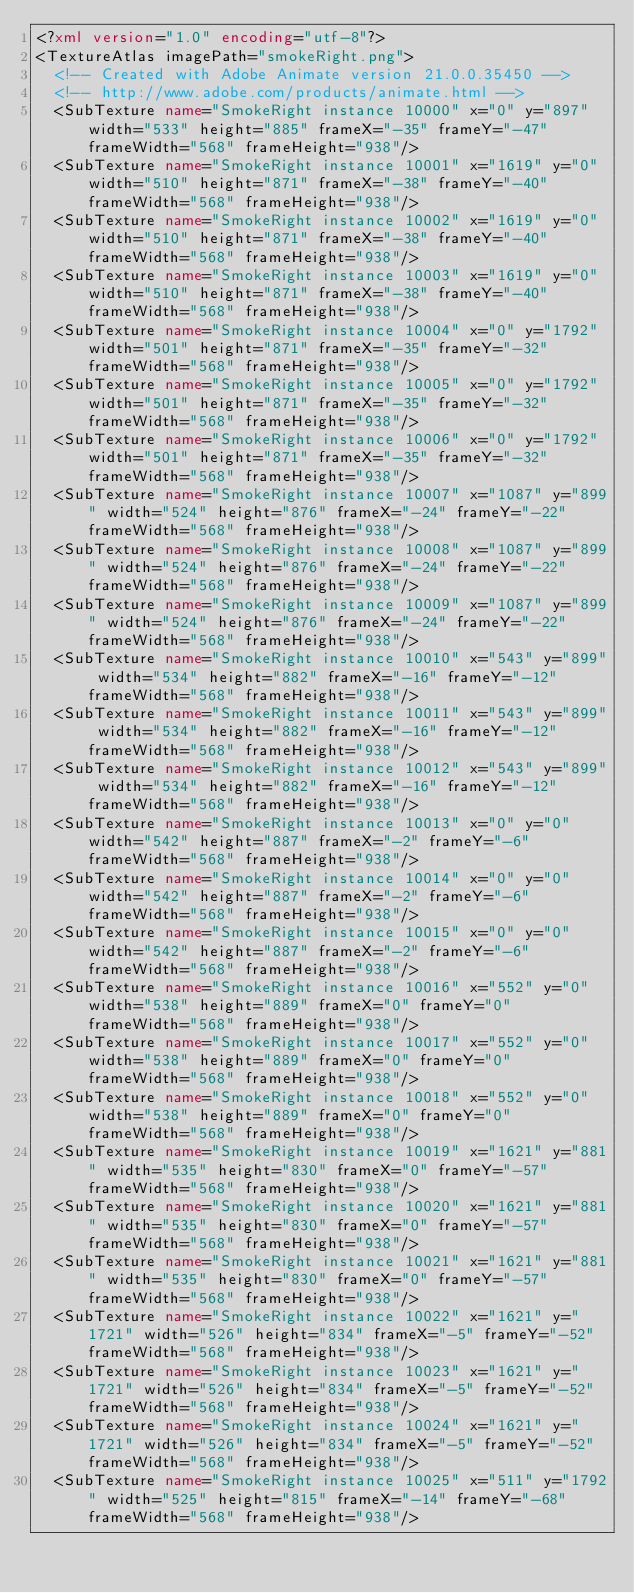<code> <loc_0><loc_0><loc_500><loc_500><_XML_><?xml version="1.0" encoding="utf-8"?>
<TextureAtlas imagePath="smokeRight.png">
	<!-- Created with Adobe Animate version 21.0.0.35450 -->
	<!-- http://www.adobe.com/products/animate.html -->
	<SubTexture name="SmokeRight instance 10000" x="0" y="897" width="533" height="885" frameX="-35" frameY="-47" frameWidth="568" frameHeight="938"/>
	<SubTexture name="SmokeRight instance 10001" x="1619" y="0" width="510" height="871" frameX="-38" frameY="-40" frameWidth="568" frameHeight="938"/>
	<SubTexture name="SmokeRight instance 10002" x="1619" y="0" width="510" height="871" frameX="-38" frameY="-40" frameWidth="568" frameHeight="938"/>
	<SubTexture name="SmokeRight instance 10003" x="1619" y="0" width="510" height="871" frameX="-38" frameY="-40" frameWidth="568" frameHeight="938"/>
	<SubTexture name="SmokeRight instance 10004" x="0" y="1792" width="501" height="871" frameX="-35" frameY="-32" frameWidth="568" frameHeight="938"/>
	<SubTexture name="SmokeRight instance 10005" x="0" y="1792" width="501" height="871" frameX="-35" frameY="-32" frameWidth="568" frameHeight="938"/>
	<SubTexture name="SmokeRight instance 10006" x="0" y="1792" width="501" height="871" frameX="-35" frameY="-32" frameWidth="568" frameHeight="938"/>
	<SubTexture name="SmokeRight instance 10007" x="1087" y="899" width="524" height="876" frameX="-24" frameY="-22" frameWidth="568" frameHeight="938"/>
	<SubTexture name="SmokeRight instance 10008" x="1087" y="899" width="524" height="876" frameX="-24" frameY="-22" frameWidth="568" frameHeight="938"/>
	<SubTexture name="SmokeRight instance 10009" x="1087" y="899" width="524" height="876" frameX="-24" frameY="-22" frameWidth="568" frameHeight="938"/>
	<SubTexture name="SmokeRight instance 10010" x="543" y="899" width="534" height="882" frameX="-16" frameY="-12" frameWidth="568" frameHeight="938"/>
	<SubTexture name="SmokeRight instance 10011" x="543" y="899" width="534" height="882" frameX="-16" frameY="-12" frameWidth="568" frameHeight="938"/>
	<SubTexture name="SmokeRight instance 10012" x="543" y="899" width="534" height="882" frameX="-16" frameY="-12" frameWidth="568" frameHeight="938"/>
	<SubTexture name="SmokeRight instance 10013" x="0" y="0" width="542" height="887" frameX="-2" frameY="-6" frameWidth="568" frameHeight="938"/>
	<SubTexture name="SmokeRight instance 10014" x="0" y="0" width="542" height="887" frameX="-2" frameY="-6" frameWidth="568" frameHeight="938"/>
	<SubTexture name="SmokeRight instance 10015" x="0" y="0" width="542" height="887" frameX="-2" frameY="-6" frameWidth="568" frameHeight="938"/>
	<SubTexture name="SmokeRight instance 10016" x="552" y="0" width="538" height="889" frameX="0" frameY="0" frameWidth="568" frameHeight="938"/>
	<SubTexture name="SmokeRight instance 10017" x="552" y="0" width="538" height="889" frameX="0" frameY="0" frameWidth="568" frameHeight="938"/>
	<SubTexture name="SmokeRight instance 10018" x="552" y="0" width="538" height="889" frameX="0" frameY="0" frameWidth="568" frameHeight="938"/>
	<SubTexture name="SmokeRight instance 10019" x="1621" y="881" width="535" height="830" frameX="0" frameY="-57" frameWidth="568" frameHeight="938"/>
	<SubTexture name="SmokeRight instance 10020" x="1621" y="881" width="535" height="830" frameX="0" frameY="-57" frameWidth="568" frameHeight="938"/>
	<SubTexture name="SmokeRight instance 10021" x="1621" y="881" width="535" height="830" frameX="0" frameY="-57" frameWidth="568" frameHeight="938"/>
	<SubTexture name="SmokeRight instance 10022" x="1621" y="1721" width="526" height="834" frameX="-5" frameY="-52" frameWidth="568" frameHeight="938"/>
	<SubTexture name="SmokeRight instance 10023" x="1621" y="1721" width="526" height="834" frameX="-5" frameY="-52" frameWidth="568" frameHeight="938"/>
	<SubTexture name="SmokeRight instance 10024" x="1621" y="1721" width="526" height="834" frameX="-5" frameY="-52" frameWidth="568" frameHeight="938"/>
	<SubTexture name="SmokeRight instance 10025" x="511" y="1792" width="525" height="815" frameX="-14" frameY="-68" frameWidth="568" frameHeight="938"/></code> 